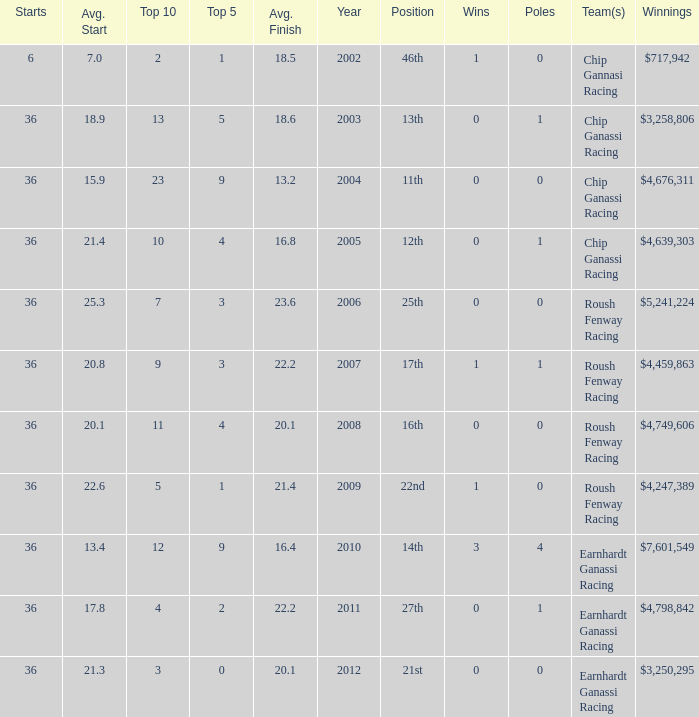Name the poles for 25th position 0.0. 